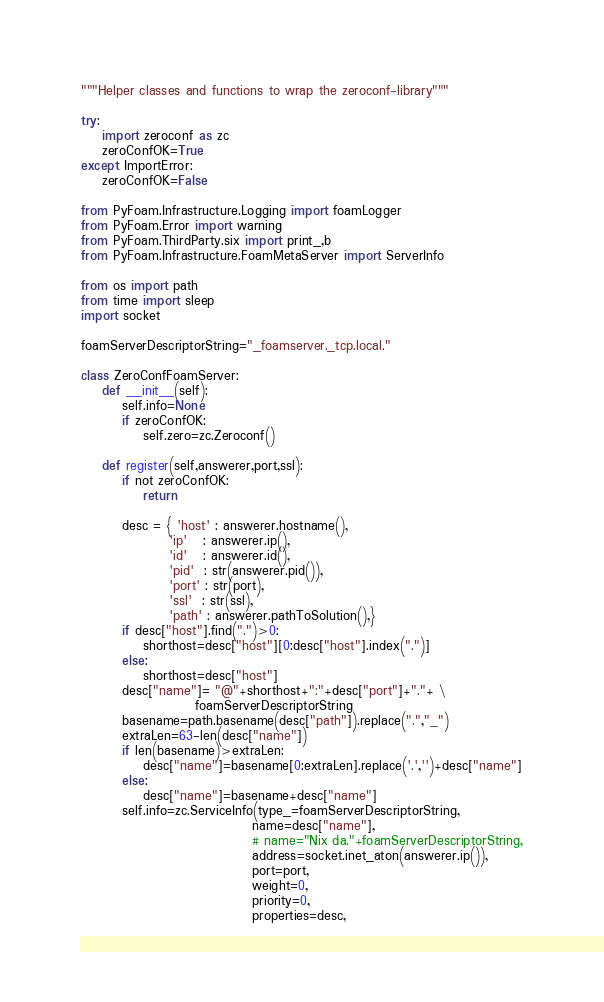<code> <loc_0><loc_0><loc_500><loc_500><_Python_>"""Helper classes and functions to wrap the zeroconf-library"""

try:
    import zeroconf as zc
    zeroConfOK=True
except ImportError:
    zeroConfOK=False

from PyFoam.Infrastructure.Logging import foamLogger
from PyFoam.Error import warning
from PyFoam.ThirdParty.six import print_,b
from PyFoam.Infrastructure.FoamMetaServer import ServerInfo

from os import path
from time import sleep
import socket

foamServerDescriptorString="_foamserver._tcp.local."

class ZeroConfFoamServer:
    def __init__(self):
        self.info=None
        if zeroConfOK:
            self.zero=zc.Zeroconf()

    def register(self,answerer,port,ssl):
        if not zeroConfOK:
            return

        desc = { 'host' : answerer.hostname(),
                 'ip'   : answerer.ip(),
                 'id'   : answerer.id(),
                 'pid'  : str(answerer.pid()),
                 'port' : str(port),
                 'ssl'  : str(ssl),
                 'path' : answerer.pathToSolution(),}
        if desc["host"].find(".")>0:
            shorthost=desc["host"][0:desc["host"].index(".")]
        else:
            shorthost=desc["host"]
        desc["name"]= "@"+shorthost+":"+desc["port"]+"."+ \
                      foamServerDescriptorString
        basename=path.basename(desc["path"]).replace(".","_")
        extraLen=63-len(desc["name"])
        if len(basename)>extraLen:
            desc["name"]=basename[0:extraLen].replace('.','')+desc["name"]
        else:
            desc["name"]=basename+desc["name"]
        self.info=zc.ServiceInfo(type_=foamServerDescriptorString,
                                 name=desc["name"],
                                 # name="Nix da."+foamServerDescriptorString,
                                 address=socket.inet_aton(answerer.ip()),
                                 port=port,
                                 weight=0,
                                 priority=0,
                                 properties=desc,</code> 